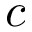Convert formula to latex. <formula><loc_0><loc_0><loc_500><loc_500>c</formula> 